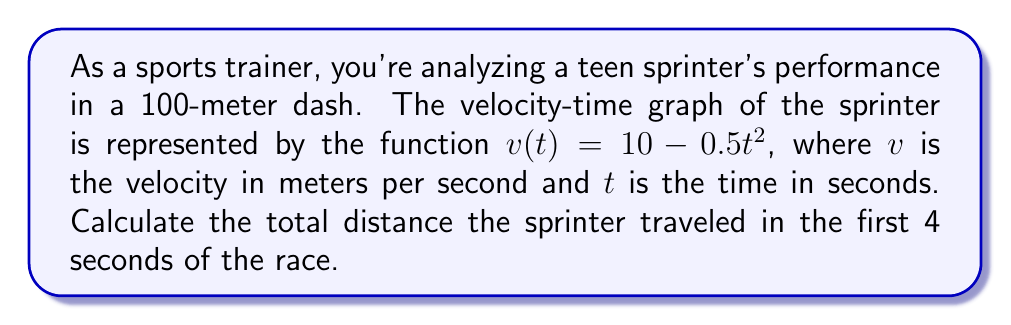Teach me how to tackle this problem. To solve this problem, we need to find the area under the velocity-time curve from $t=0$ to $t=4$. This area represents the total distance traveled.

1) The distance traveled is given by the definite integral of the velocity function:

   $$d = \int_0^4 v(t) dt = \int_0^4 (10 - 0.5t^2) dt$$

2) Let's integrate this function:
   
   $$\int_0^4 (10 - 0.5t^2) dt = [10t - \frac{1}{6}t^3]_0^4$$

3) Now, let's evaluate this definite integral:

   $$[10t - \frac{1}{6}t^3]_0^4 = (40 - \frac{64}{6}) - (0 - 0)$$

4) Simplify:
   
   $$40 - \frac{64}{6} = 40 - \frac{32}{3} = \frac{120}{3} - \frac{32}{3} = \frac{88}{3}$$

Therefore, the total distance traveled in the first 4 seconds is $\frac{88}{3}$ meters.
Answer: $\frac{88}{3}$ meters or approximately 29.33 meters 